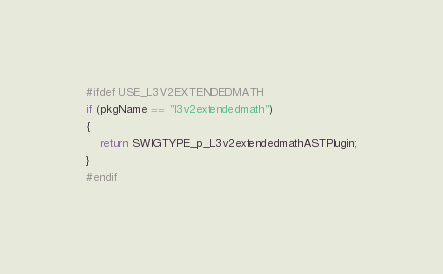<code> <loc_0><loc_0><loc_500><loc_500><_C++_>
#ifdef USE_L3V2EXTENDEDMATH
if (pkgName == "l3v2extendedmath")
{		
	return SWIGTYPE_p_L3v2extendedmathASTPlugin;
}
#endif	

</code> 